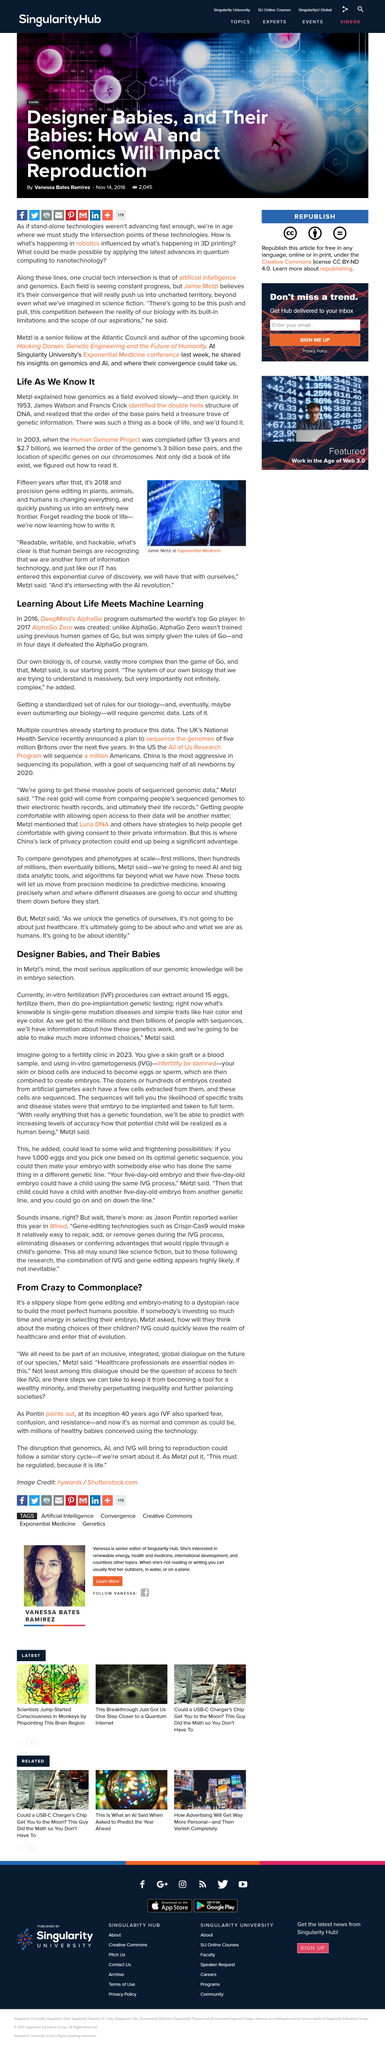Highlight a few significant elements in this photo. In an IVF procedure, approximately 15 eggs can be extracted. The three letter abbreviation for in-vitro fertilization is IVF. After identifying the double helix structure of DNA, it was realized that the order of the base pairs held a treasure trove of genetic information. James Watson and Francis Crick identified the double helix structure of DNA in 1953. The year in which AlphaGo Zero was created was 2017. 